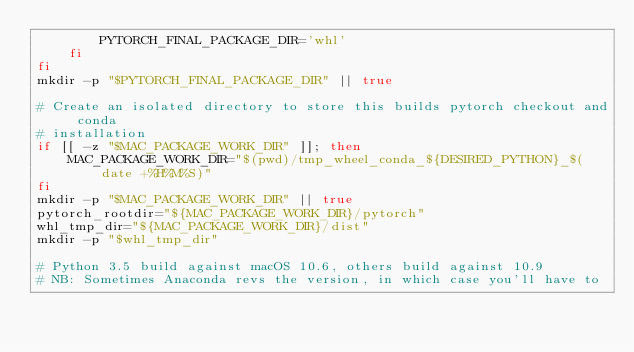<code> <loc_0><loc_0><loc_500><loc_500><_Bash_>        PYTORCH_FINAL_PACKAGE_DIR='whl'
    fi
fi
mkdir -p "$PYTORCH_FINAL_PACKAGE_DIR" || true

# Create an isolated directory to store this builds pytorch checkout and conda
# installation
if [[ -z "$MAC_PACKAGE_WORK_DIR" ]]; then
    MAC_PACKAGE_WORK_DIR="$(pwd)/tmp_wheel_conda_${DESIRED_PYTHON}_$(date +%H%M%S)"
fi
mkdir -p "$MAC_PACKAGE_WORK_DIR" || true
pytorch_rootdir="${MAC_PACKAGE_WORK_DIR}/pytorch"
whl_tmp_dir="${MAC_PACKAGE_WORK_DIR}/dist"
mkdir -p "$whl_tmp_dir"

# Python 3.5 build against macOS 10.6, others build against 10.9
# NB: Sometimes Anaconda revs the version, in which case you'll have to</code> 